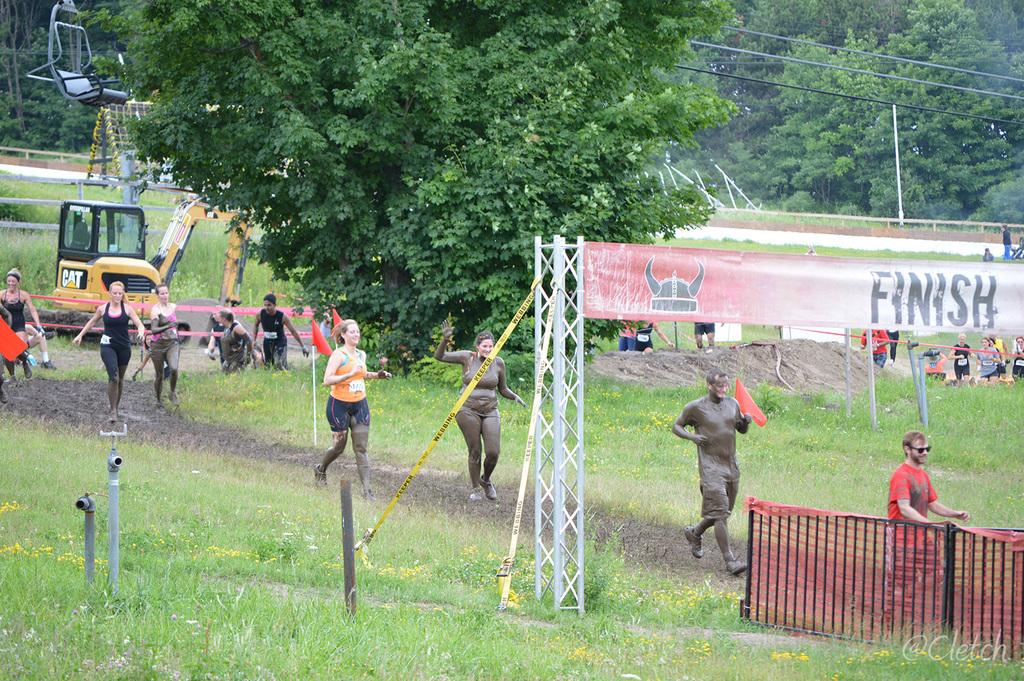What does the banner say?
Provide a succinct answer. Finish. What is the name on the yellow equipment in the background?
Provide a short and direct response. Cat. 